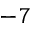Convert formula to latex. <formula><loc_0><loc_0><loc_500><loc_500>^ { - 7 }</formula> 